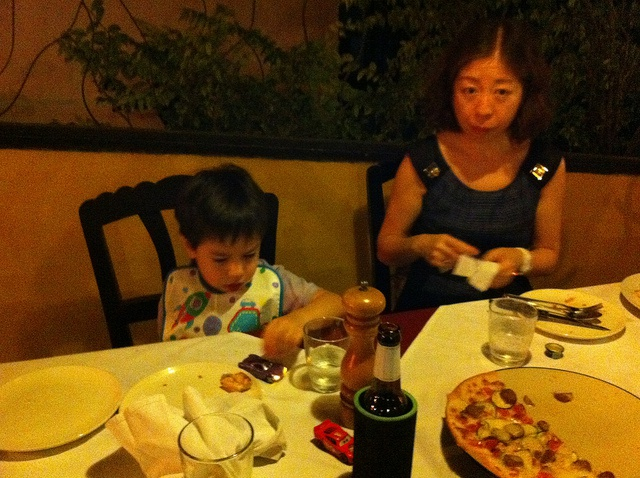Describe the objects in this image and their specific colors. I can see dining table in maroon, orange, olive, black, and gold tones, people in maroon, black, and brown tones, people in maroon, black, and olive tones, chair in maroon and black tones, and pizza in maroon, red, and orange tones in this image. 